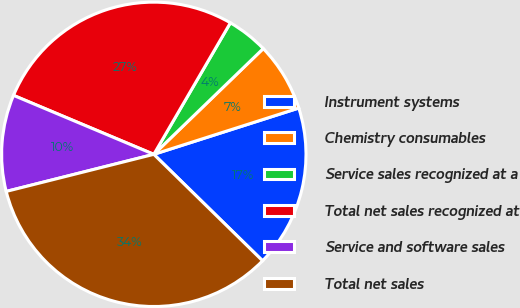<chart> <loc_0><loc_0><loc_500><loc_500><pie_chart><fcel>Instrument systems<fcel>Chemistry consumables<fcel>Service sales recognized at a<fcel>Total net sales recognized at<fcel>Service and software sales<fcel>Total net sales<nl><fcel>17.25%<fcel>7.31%<fcel>4.38%<fcel>27.06%<fcel>10.25%<fcel>33.75%<nl></chart> 